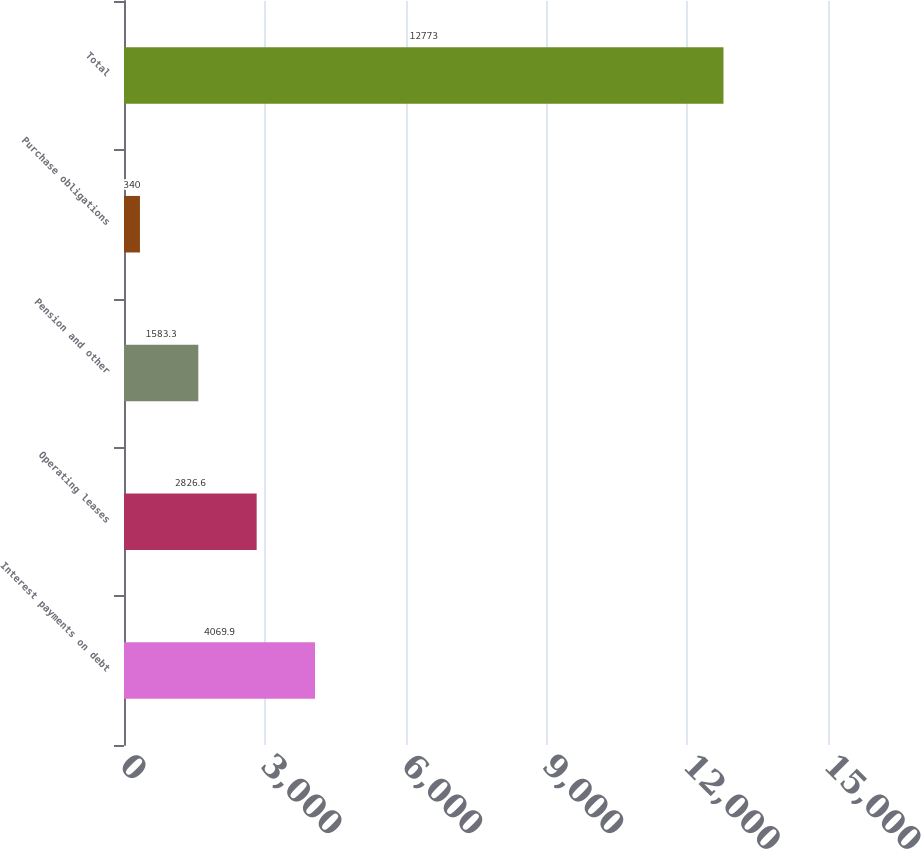Convert chart. <chart><loc_0><loc_0><loc_500><loc_500><bar_chart><fcel>Interest payments on debt<fcel>Operating leases<fcel>Pension and other<fcel>Purchase obligations<fcel>Total<nl><fcel>4069.9<fcel>2826.6<fcel>1583.3<fcel>340<fcel>12773<nl></chart> 